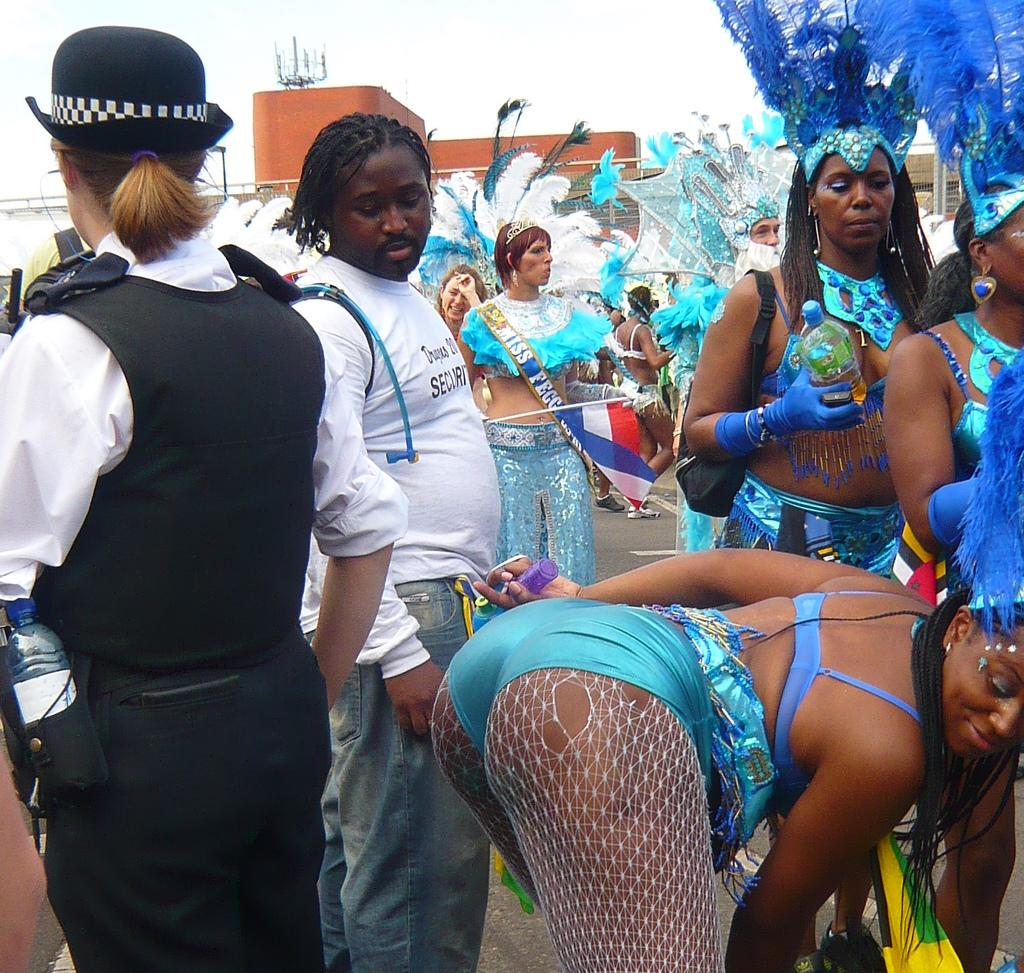How many people are visible at the bottom of the image? There are persons at the bottom of the image, but the exact number is not specified. What is the person in the foreground doing? One person is bending and smiling. What can be seen in the background of the image? There is a building in the background of the image. What is visible in the sky? There are clouds in the sky. What type of curtain can be seen hanging from the building in the image? There is no curtain visible in the image; only the building and clouds are present. Are there any animals from a zoo or prisoners from a prison in the image? There is no mention of a zoo or prison in the image, and no such individuals are visible. 